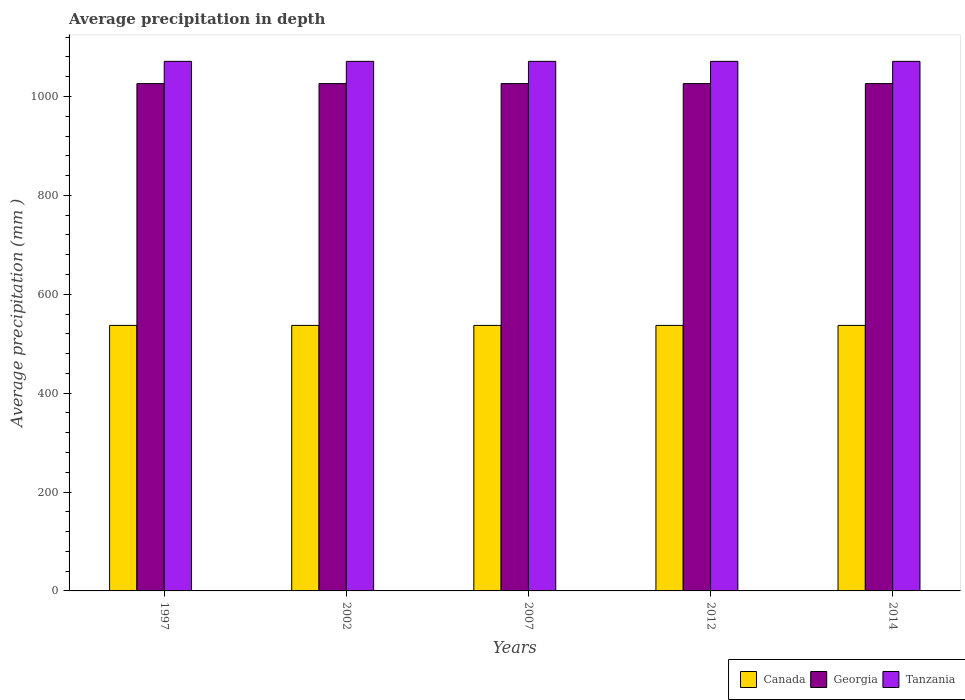How many groups of bars are there?
Your response must be concise. 5. Are the number of bars on each tick of the X-axis equal?
Ensure brevity in your answer.  Yes. How many bars are there on the 1st tick from the left?
Keep it short and to the point. 3. How many bars are there on the 3rd tick from the right?
Give a very brief answer. 3. What is the label of the 5th group of bars from the left?
Your answer should be compact. 2014. What is the average precipitation in Canada in 2012?
Your answer should be compact. 537. Across all years, what is the maximum average precipitation in Tanzania?
Give a very brief answer. 1071. Across all years, what is the minimum average precipitation in Georgia?
Ensure brevity in your answer.  1026. In which year was the average precipitation in Georgia maximum?
Your answer should be very brief. 1997. What is the total average precipitation in Canada in the graph?
Give a very brief answer. 2685. What is the difference between the average precipitation in Tanzania in 2007 and that in 2014?
Give a very brief answer. 0. What is the difference between the average precipitation in Georgia in 1997 and the average precipitation in Canada in 2014?
Your answer should be compact. 489. What is the average average precipitation in Canada per year?
Give a very brief answer. 537. In the year 2014, what is the difference between the average precipitation in Canada and average precipitation in Georgia?
Provide a succinct answer. -489. In how many years, is the average precipitation in Tanzania greater than 160 mm?
Your answer should be very brief. 5. What is the ratio of the average precipitation in Georgia in 1997 to that in 2007?
Ensure brevity in your answer.  1. Is the difference between the average precipitation in Canada in 1997 and 2014 greater than the difference between the average precipitation in Georgia in 1997 and 2014?
Ensure brevity in your answer.  No. What does the 2nd bar from the left in 2002 represents?
Your response must be concise. Georgia. What does the 1st bar from the right in 2012 represents?
Your response must be concise. Tanzania. Are all the bars in the graph horizontal?
Keep it short and to the point. No. What is the difference between two consecutive major ticks on the Y-axis?
Offer a very short reply. 200. Are the values on the major ticks of Y-axis written in scientific E-notation?
Provide a short and direct response. No. What is the title of the graph?
Your answer should be very brief. Average precipitation in depth. Does "Finland" appear as one of the legend labels in the graph?
Give a very brief answer. No. What is the label or title of the Y-axis?
Your answer should be very brief. Average precipitation (mm ). What is the Average precipitation (mm ) in Canada in 1997?
Your answer should be compact. 537. What is the Average precipitation (mm ) in Georgia in 1997?
Provide a succinct answer. 1026. What is the Average precipitation (mm ) in Tanzania in 1997?
Ensure brevity in your answer.  1071. What is the Average precipitation (mm ) in Canada in 2002?
Make the answer very short. 537. What is the Average precipitation (mm ) in Georgia in 2002?
Provide a short and direct response. 1026. What is the Average precipitation (mm ) in Tanzania in 2002?
Your answer should be compact. 1071. What is the Average precipitation (mm ) in Canada in 2007?
Provide a succinct answer. 537. What is the Average precipitation (mm ) in Georgia in 2007?
Offer a very short reply. 1026. What is the Average precipitation (mm ) of Tanzania in 2007?
Make the answer very short. 1071. What is the Average precipitation (mm ) in Canada in 2012?
Make the answer very short. 537. What is the Average precipitation (mm ) in Georgia in 2012?
Offer a terse response. 1026. What is the Average precipitation (mm ) in Tanzania in 2012?
Give a very brief answer. 1071. What is the Average precipitation (mm ) in Canada in 2014?
Ensure brevity in your answer.  537. What is the Average precipitation (mm ) in Georgia in 2014?
Make the answer very short. 1026. What is the Average precipitation (mm ) of Tanzania in 2014?
Keep it short and to the point. 1071. Across all years, what is the maximum Average precipitation (mm ) of Canada?
Ensure brevity in your answer.  537. Across all years, what is the maximum Average precipitation (mm ) of Georgia?
Your answer should be compact. 1026. Across all years, what is the maximum Average precipitation (mm ) in Tanzania?
Make the answer very short. 1071. Across all years, what is the minimum Average precipitation (mm ) in Canada?
Ensure brevity in your answer.  537. Across all years, what is the minimum Average precipitation (mm ) of Georgia?
Give a very brief answer. 1026. Across all years, what is the minimum Average precipitation (mm ) in Tanzania?
Provide a succinct answer. 1071. What is the total Average precipitation (mm ) in Canada in the graph?
Provide a succinct answer. 2685. What is the total Average precipitation (mm ) in Georgia in the graph?
Offer a terse response. 5130. What is the total Average precipitation (mm ) of Tanzania in the graph?
Offer a terse response. 5355. What is the difference between the Average precipitation (mm ) in Tanzania in 1997 and that in 2002?
Provide a short and direct response. 0. What is the difference between the Average precipitation (mm ) in Georgia in 1997 and that in 2007?
Provide a succinct answer. 0. What is the difference between the Average precipitation (mm ) in Tanzania in 1997 and that in 2007?
Offer a terse response. 0. What is the difference between the Average precipitation (mm ) in Canada in 1997 and that in 2012?
Ensure brevity in your answer.  0. What is the difference between the Average precipitation (mm ) in Georgia in 1997 and that in 2012?
Provide a short and direct response. 0. What is the difference between the Average precipitation (mm ) of Canada in 1997 and that in 2014?
Offer a very short reply. 0. What is the difference between the Average precipitation (mm ) of Georgia in 1997 and that in 2014?
Make the answer very short. 0. What is the difference between the Average precipitation (mm ) in Tanzania in 1997 and that in 2014?
Make the answer very short. 0. What is the difference between the Average precipitation (mm ) of Canada in 2002 and that in 2007?
Ensure brevity in your answer.  0. What is the difference between the Average precipitation (mm ) in Georgia in 2002 and that in 2007?
Keep it short and to the point. 0. What is the difference between the Average precipitation (mm ) in Canada in 2002 and that in 2012?
Keep it short and to the point. 0. What is the difference between the Average precipitation (mm ) in Canada in 2002 and that in 2014?
Your response must be concise. 0. What is the difference between the Average precipitation (mm ) of Canada in 2007 and that in 2012?
Your answer should be very brief. 0. What is the difference between the Average precipitation (mm ) in Georgia in 2007 and that in 2012?
Offer a terse response. 0. What is the difference between the Average precipitation (mm ) in Canada in 2007 and that in 2014?
Offer a terse response. 0. What is the difference between the Average precipitation (mm ) in Canada in 2012 and that in 2014?
Your response must be concise. 0. What is the difference between the Average precipitation (mm ) of Tanzania in 2012 and that in 2014?
Offer a very short reply. 0. What is the difference between the Average precipitation (mm ) of Canada in 1997 and the Average precipitation (mm ) of Georgia in 2002?
Keep it short and to the point. -489. What is the difference between the Average precipitation (mm ) of Canada in 1997 and the Average precipitation (mm ) of Tanzania in 2002?
Your answer should be compact. -534. What is the difference between the Average precipitation (mm ) in Georgia in 1997 and the Average precipitation (mm ) in Tanzania in 2002?
Your response must be concise. -45. What is the difference between the Average precipitation (mm ) of Canada in 1997 and the Average precipitation (mm ) of Georgia in 2007?
Provide a short and direct response. -489. What is the difference between the Average precipitation (mm ) of Canada in 1997 and the Average precipitation (mm ) of Tanzania in 2007?
Ensure brevity in your answer.  -534. What is the difference between the Average precipitation (mm ) in Georgia in 1997 and the Average precipitation (mm ) in Tanzania in 2007?
Your response must be concise. -45. What is the difference between the Average precipitation (mm ) of Canada in 1997 and the Average precipitation (mm ) of Georgia in 2012?
Give a very brief answer. -489. What is the difference between the Average precipitation (mm ) of Canada in 1997 and the Average precipitation (mm ) of Tanzania in 2012?
Offer a very short reply. -534. What is the difference between the Average precipitation (mm ) of Georgia in 1997 and the Average precipitation (mm ) of Tanzania in 2012?
Offer a very short reply. -45. What is the difference between the Average precipitation (mm ) of Canada in 1997 and the Average precipitation (mm ) of Georgia in 2014?
Provide a short and direct response. -489. What is the difference between the Average precipitation (mm ) in Canada in 1997 and the Average precipitation (mm ) in Tanzania in 2014?
Your answer should be compact. -534. What is the difference between the Average precipitation (mm ) of Georgia in 1997 and the Average precipitation (mm ) of Tanzania in 2014?
Provide a succinct answer. -45. What is the difference between the Average precipitation (mm ) of Canada in 2002 and the Average precipitation (mm ) of Georgia in 2007?
Offer a very short reply. -489. What is the difference between the Average precipitation (mm ) of Canada in 2002 and the Average precipitation (mm ) of Tanzania in 2007?
Your answer should be very brief. -534. What is the difference between the Average precipitation (mm ) in Georgia in 2002 and the Average precipitation (mm ) in Tanzania in 2007?
Your response must be concise. -45. What is the difference between the Average precipitation (mm ) of Canada in 2002 and the Average precipitation (mm ) of Georgia in 2012?
Keep it short and to the point. -489. What is the difference between the Average precipitation (mm ) of Canada in 2002 and the Average precipitation (mm ) of Tanzania in 2012?
Give a very brief answer. -534. What is the difference between the Average precipitation (mm ) in Georgia in 2002 and the Average precipitation (mm ) in Tanzania in 2012?
Offer a very short reply. -45. What is the difference between the Average precipitation (mm ) of Canada in 2002 and the Average precipitation (mm ) of Georgia in 2014?
Your response must be concise. -489. What is the difference between the Average precipitation (mm ) in Canada in 2002 and the Average precipitation (mm ) in Tanzania in 2014?
Make the answer very short. -534. What is the difference between the Average precipitation (mm ) of Georgia in 2002 and the Average precipitation (mm ) of Tanzania in 2014?
Ensure brevity in your answer.  -45. What is the difference between the Average precipitation (mm ) in Canada in 2007 and the Average precipitation (mm ) in Georgia in 2012?
Your answer should be compact. -489. What is the difference between the Average precipitation (mm ) of Canada in 2007 and the Average precipitation (mm ) of Tanzania in 2012?
Make the answer very short. -534. What is the difference between the Average precipitation (mm ) of Georgia in 2007 and the Average precipitation (mm ) of Tanzania in 2012?
Your answer should be compact. -45. What is the difference between the Average precipitation (mm ) in Canada in 2007 and the Average precipitation (mm ) in Georgia in 2014?
Provide a succinct answer. -489. What is the difference between the Average precipitation (mm ) of Canada in 2007 and the Average precipitation (mm ) of Tanzania in 2014?
Provide a short and direct response. -534. What is the difference between the Average precipitation (mm ) in Georgia in 2007 and the Average precipitation (mm ) in Tanzania in 2014?
Ensure brevity in your answer.  -45. What is the difference between the Average precipitation (mm ) in Canada in 2012 and the Average precipitation (mm ) in Georgia in 2014?
Offer a very short reply. -489. What is the difference between the Average precipitation (mm ) of Canada in 2012 and the Average precipitation (mm ) of Tanzania in 2014?
Offer a very short reply. -534. What is the difference between the Average precipitation (mm ) in Georgia in 2012 and the Average precipitation (mm ) in Tanzania in 2014?
Your response must be concise. -45. What is the average Average precipitation (mm ) of Canada per year?
Keep it short and to the point. 537. What is the average Average precipitation (mm ) in Georgia per year?
Keep it short and to the point. 1026. What is the average Average precipitation (mm ) in Tanzania per year?
Keep it short and to the point. 1071. In the year 1997, what is the difference between the Average precipitation (mm ) in Canada and Average precipitation (mm ) in Georgia?
Keep it short and to the point. -489. In the year 1997, what is the difference between the Average precipitation (mm ) in Canada and Average precipitation (mm ) in Tanzania?
Ensure brevity in your answer.  -534. In the year 1997, what is the difference between the Average precipitation (mm ) in Georgia and Average precipitation (mm ) in Tanzania?
Give a very brief answer. -45. In the year 2002, what is the difference between the Average precipitation (mm ) in Canada and Average precipitation (mm ) in Georgia?
Ensure brevity in your answer.  -489. In the year 2002, what is the difference between the Average precipitation (mm ) of Canada and Average precipitation (mm ) of Tanzania?
Offer a very short reply. -534. In the year 2002, what is the difference between the Average precipitation (mm ) of Georgia and Average precipitation (mm ) of Tanzania?
Ensure brevity in your answer.  -45. In the year 2007, what is the difference between the Average precipitation (mm ) of Canada and Average precipitation (mm ) of Georgia?
Provide a short and direct response. -489. In the year 2007, what is the difference between the Average precipitation (mm ) of Canada and Average precipitation (mm ) of Tanzania?
Offer a terse response. -534. In the year 2007, what is the difference between the Average precipitation (mm ) in Georgia and Average precipitation (mm ) in Tanzania?
Ensure brevity in your answer.  -45. In the year 2012, what is the difference between the Average precipitation (mm ) of Canada and Average precipitation (mm ) of Georgia?
Your response must be concise. -489. In the year 2012, what is the difference between the Average precipitation (mm ) in Canada and Average precipitation (mm ) in Tanzania?
Offer a terse response. -534. In the year 2012, what is the difference between the Average precipitation (mm ) of Georgia and Average precipitation (mm ) of Tanzania?
Provide a short and direct response. -45. In the year 2014, what is the difference between the Average precipitation (mm ) of Canada and Average precipitation (mm ) of Georgia?
Keep it short and to the point. -489. In the year 2014, what is the difference between the Average precipitation (mm ) in Canada and Average precipitation (mm ) in Tanzania?
Your answer should be compact. -534. In the year 2014, what is the difference between the Average precipitation (mm ) of Georgia and Average precipitation (mm ) of Tanzania?
Your answer should be compact. -45. What is the ratio of the Average precipitation (mm ) of Tanzania in 1997 to that in 2007?
Provide a short and direct response. 1. What is the ratio of the Average precipitation (mm ) of Canada in 1997 to that in 2012?
Your answer should be very brief. 1. What is the ratio of the Average precipitation (mm ) of Georgia in 1997 to that in 2012?
Offer a terse response. 1. What is the ratio of the Average precipitation (mm ) of Georgia in 1997 to that in 2014?
Keep it short and to the point. 1. What is the ratio of the Average precipitation (mm ) of Canada in 2002 to that in 2007?
Give a very brief answer. 1. What is the ratio of the Average precipitation (mm ) of Tanzania in 2002 to that in 2007?
Give a very brief answer. 1. What is the ratio of the Average precipitation (mm ) of Georgia in 2002 to that in 2012?
Provide a succinct answer. 1. What is the ratio of the Average precipitation (mm ) in Georgia in 2002 to that in 2014?
Make the answer very short. 1. What is the ratio of the Average precipitation (mm ) in Tanzania in 2002 to that in 2014?
Ensure brevity in your answer.  1. What is the ratio of the Average precipitation (mm ) in Georgia in 2007 to that in 2012?
Offer a terse response. 1. What is the ratio of the Average precipitation (mm ) in Canada in 2007 to that in 2014?
Keep it short and to the point. 1. What is the ratio of the Average precipitation (mm ) in Georgia in 2007 to that in 2014?
Give a very brief answer. 1. What is the ratio of the Average precipitation (mm ) in Tanzania in 2007 to that in 2014?
Provide a succinct answer. 1. What is the ratio of the Average precipitation (mm ) in Georgia in 2012 to that in 2014?
Provide a short and direct response. 1. What is the ratio of the Average precipitation (mm ) of Tanzania in 2012 to that in 2014?
Ensure brevity in your answer.  1. What is the difference between the highest and the second highest Average precipitation (mm ) of Canada?
Provide a short and direct response. 0. What is the difference between the highest and the second highest Average precipitation (mm ) of Georgia?
Offer a terse response. 0. What is the difference between the highest and the second highest Average precipitation (mm ) in Tanzania?
Your response must be concise. 0. What is the difference between the highest and the lowest Average precipitation (mm ) of Tanzania?
Give a very brief answer. 0. 